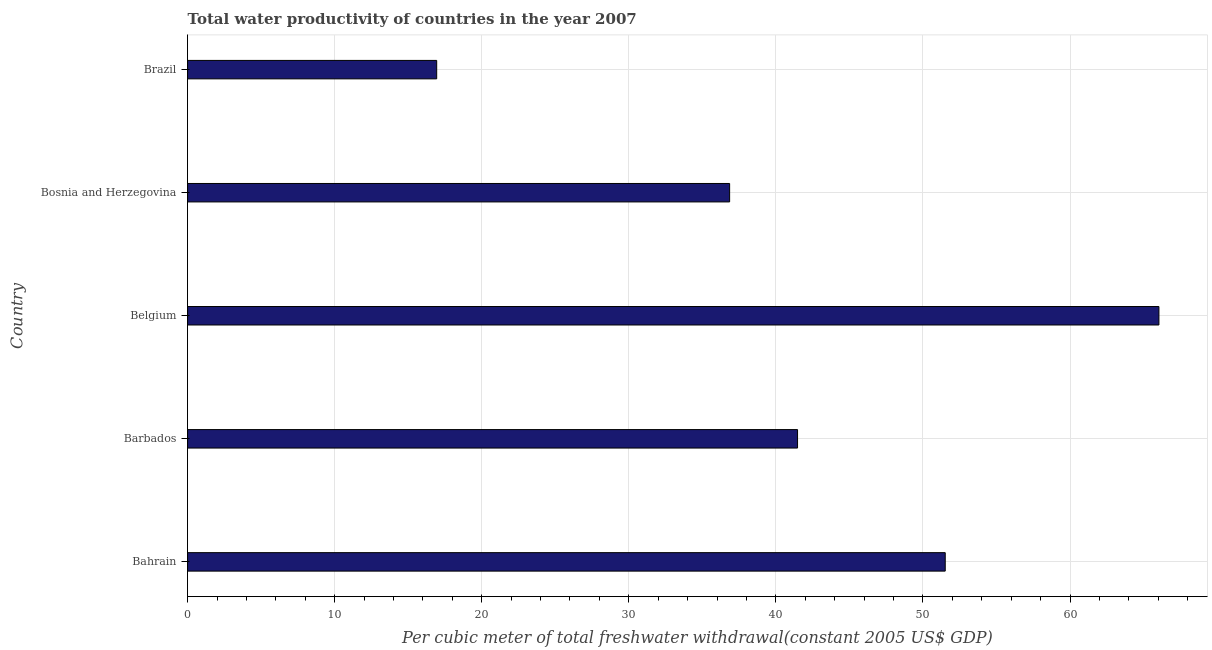Does the graph contain grids?
Make the answer very short. Yes. What is the title of the graph?
Your response must be concise. Total water productivity of countries in the year 2007. What is the label or title of the X-axis?
Offer a terse response. Per cubic meter of total freshwater withdrawal(constant 2005 US$ GDP). What is the total water productivity in Brazil?
Provide a short and direct response. 16.94. Across all countries, what is the maximum total water productivity?
Provide a short and direct response. 66.05. Across all countries, what is the minimum total water productivity?
Your response must be concise. 16.94. In which country was the total water productivity minimum?
Provide a succinct answer. Brazil. What is the sum of the total water productivity?
Provide a short and direct response. 212.83. What is the difference between the total water productivity in Belgium and Brazil?
Offer a terse response. 49.11. What is the average total water productivity per country?
Ensure brevity in your answer.  42.56. What is the median total water productivity?
Provide a succinct answer. 41.47. In how many countries, is the total water productivity greater than 34 US$?
Your answer should be very brief. 4. What is the ratio of the total water productivity in Belgium to that in Brazil?
Ensure brevity in your answer.  3.9. What is the difference between the highest and the second highest total water productivity?
Provide a short and direct response. 14.53. What is the difference between the highest and the lowest total water productivity?
Your answer should be compact. 49.11. How many bars are there?
Provide a short and direct response. 5. What is the difference between two consecutive major ticks on the X-axis?
Provide a succinct answer. 10. Are the values on the major ticks of X-axis written in scientific E-notation?
Your response must be concise. No. What is the Per cubic meter of total freshwater withdrawal(constant 2005 US$ GDP) of Bahrain?
Make the answer very short. 51.52. What is the Per cubic meter of total freshwater withdrawal(constant 2005 US$ GDP) of Barbados?
Your answer should be very brief. 41.47. What is the Per cubic meter of total freshwater withdrawal(constant 2005 US$ GDP) in Belgium?
Provide a short and direct response. 66.05. What is the Per cubic meter of total freshwater withdrawal(constant 2005 US$ GDP) in Bosnia and Herzegovina?
Give a very brief answer. 36.86. What is the Per cubic meter of total freshwater withdrawal(constant 2005 US$ GDP) of Brazil?
Offer a very short reply. 16.94. What is the difference between the Per cubic meter of total freshwater withdrawal(constant 2005 US$ GDP) in Bahrain and Barbados?
Make the answer very short. 10.04. What is the difference between the Per cubic meter of total freshwater withdrawal(constant 2005 US$ GDP) in Bahrain and Belgium?
Your answer should be very brief. -14.53. What is the difference between the Per cubic meter of total freshwater withdrawal(constant 2005 US$ GDP) in Bahrain and Bosnia and Herzegovina?
Offer a very short reply. 14.66. What is the difference between the Per cubic meter of total freshwater withdrawal(constant 2005 US$ GDP) in Bahrain and Brazil?
Your answer should be very brief. 34.58. What is the difference between the Per cubic meter of total freshwater withdrawal(constant 2005 US$ GDP) in Barbados and Belgium?
Offer a very short reply. -24.57. What is the difference between the Per cubic meter of total freshwater withdrawal(constant 2005 US$ GDP) in Barbados and Bosnia and Herzegovina?
Make the answer very short. 4.62. What is the difference between the Per cubic meter of total freshwater withdrawal(constant 2005 US$ GDP) in Barbados and Brazil?
Offer a terse response. 24.54. What is the difference between the Per cubic meter of total freshwater withdrawal(constant 2005 US$ GDP) in Belgium and Bosnia and Herzegovina?
Ensure brevity in your answer.  29.19. What is the difference between the Per cubic meter of total freshwater withdrawal(constant 2005 US$ GDP) in Belgium and Brazil?
Keep it short and to the point. 49.11. What is the difference between the Per cubic meter of total freshwater withdrawal(constant 2005 US$ GDP) in Bosnia and Herzegovina and Brazil?
Provide a succinct answer. 19.92. What is the ratio of the Per cubic meter of total freshwater withdrawal(constant 2005 US$ GDP) in Bahrain to that in Barbados?
Provide a succinct answer. 1.24. What is the ratio of the Per cubic meter of total freshwater withdrawal(constant 2005 US$ GDP) in Bahrain to that in Belgium?
Your answer should be very brief. 0.78. What is the ratio of the Per cubic meter of total freshwater withdrawal(constant 2005 US$ GDP) in Bahrain to that in Bosnia and Herzegovina?
Ensure brevity in your answer.  1.4. What is the ratio of the Per cubic meter of total freshwater withdrawal(constant 2005 US$ GDP) in Bahrain to that in Brazil?
Provide a succinct answer. 3.04. What is the ratio of the Per cubic meter of total freshwater withdrawal(constant 2005 US$ GDP) in Barbados to that in Belgium?
Make the answer very short. 0.63. What is the ratio of the Per cubic meter of total freshwater withdrawal(constant 2005 US$ GDP) in Barbados to that in Brazil?
Your answer should be compact. 2.45. What is the ratio of the Per cubic meter of total freshwater withdrawal(constant 2005 US$ GDP) in Belgium to that in Bosnia and Herzegovina?
Ensure brevity in your answer.  1.79. What is the ratio of the Per cubic meter of total freshwater withdrawal(constant 2005 US$ GDP) in Belgium to that in Brazil?
Your answer should be compact. 3.9. What is the ratio of the Per cubic meter of total freshwater withdrawal(constant 2005 US$ GDP) in Bosnia and Herzegovina to that in Brazil?
Ensure brevity in your answer.  2.18. 